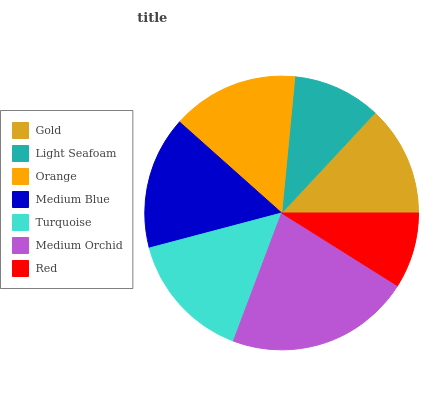Is Red the minimum?
Answer yes or no. Yes. Is Medium Orchid the maximum?
Answer yes or no. Yes. Is Light Seafoam the minimum?
Answer yes or no. No. Is Light Seafoam the maximum?
Answer yes or no. No. Is Gold greater than Light Seafoam?
Answer yes or no. Yes. Is Light Seafoam less than Gold?
Answer yes or no. Yes. Is Light Seafoam greater than Gold?
Answer yes or no. No. Is Gold less than Light Seafoam?
Answer yes or no. No. Is Orange the high median?
Answer yes or no. Yes. Is Orange the low median?
Answer yes or no. Yes. Is Red the high median?
Answer yes or no. No. Is Light Seafoam the low median?
Answer yes or no. No. 